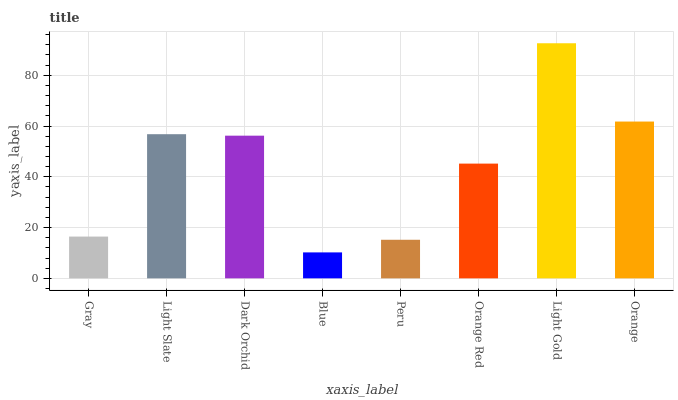Is Blue the minimum?
Answer yes or no. Yes. Is Light Gold the maximum?
Answer yes or no. Yes. Is Light Slate the minimum?
Answer yes or no. No. Is Light Slate the maximum?
Answer yes or no. No. Is Light Slate greater than Gray?
Answer yes or no. Yes. Is Gray less than Light Slate?
Answer yes or no. Yes. Is Gray greater than Light Slate?
Answer yes or no. No. Is Light Slate less than Gray?
Answer yes or no. No. Is Dark Orchid the high median?
Answer yes or no. Yes. Is Orange Red the low median?
Answer yes or no. Yes. Is Gray the high median?
Answer yes or no. No. Is Orange the low median?
Answer yes or no. No. 